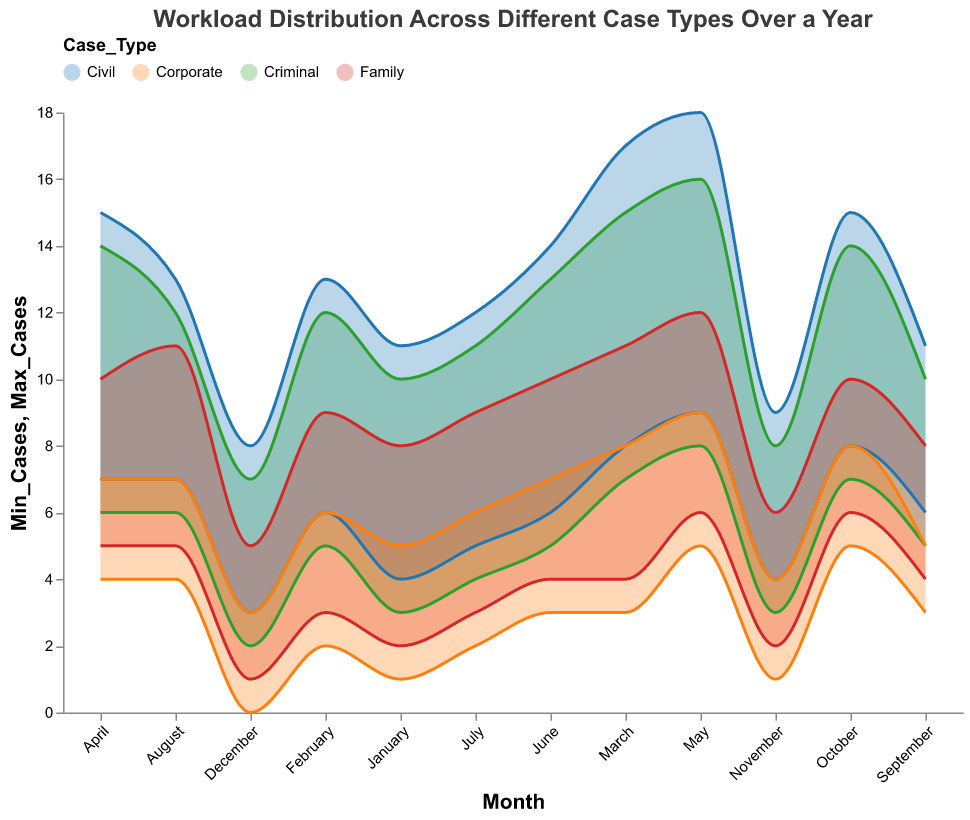What is the title of the figure? The title of the figure is usually displayed at the top. In this case, it reads "Workload Distribution Across Different Case Types Over a Year".
Answer: Workload Distribution Across Different Case Types Over a Year Which case type has the highest range of cases in March? Look at the range defined by the minimum and maximum cases for each case type in March. Civil cases have a range from 8 to 17.
Answer: Civil During which month do Criminal cases have their lowest minimum case count? Criminal cases show their lowest minimum value in December, with 2 cases.
Answer: December How many cases do Civil case types have at their maximum in May? Civil cases in May have their maximum value listed as 18 cases.
Answer: 18 Which case type shows the most stable workload across the year (smallest difference between min and max cases)? Calculate the average range (difference between min and max) for all case types. Corporate cases show a relatively small range over the year.
Answer: Corporate What is the difference between the maximum number of cases for Family and Corporate cases in October? In October, Family cases have a maximum of 10 and Corporate cases have a maximum of 8, so the difference is 2.
Answer: 2 Which month shows the maximum range (difference between Min and Max cases) for any case type? March shows the maximum range for Civil cases, with a difference of 17 - 8 = 9.
Answer: March Do Family cases always have fewer cases than Civil cases each month? For each month, compare the maximum values of Family cases and Civil cases. Civil cases are always greater than Family cases.
Answer: Yes In which month do Corporate cases experience their minimum workload? Observe the minimum values for Corporate cases. The lowest value is 0 cases in December.
Answer: December How does the workload of Criminal cases in July compare to their workload in September? Criminal cases in July range from 4 to 11, while in September they range from 5 to 10. Both the minimum and maximum numbers are higher in July than in September.
Answer: Higher in July 